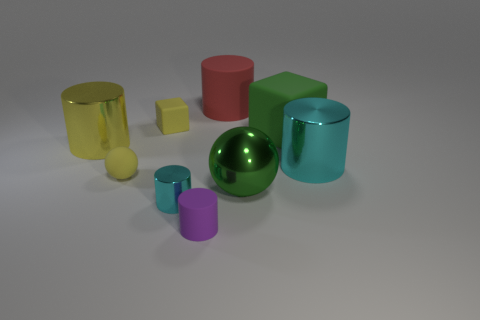Subtract all small rubber cylinders. How many cylinders are left? 4 Subtract 1 blocks. How many blocks are left? 1 Subtract all purple cylinders. How many cylinders are left? 4 Subtract all gray spheres. How many yellow blocks are left? 1 Subtract all shiny cylinders. Subtract all yellow objects. How many objects are left? 3 Add 6 green spheres. How many green spheres are left? 7 Add 4 small green matte spheres. How many small green matte spheres exist? 4 Subtract 1 yellow blocks. How many objects are left? 8 Subtract all cubes. How many objects are left? 7 Subtract all blue cubes. Subtract all red cylinders. How many cubes are left? 2 